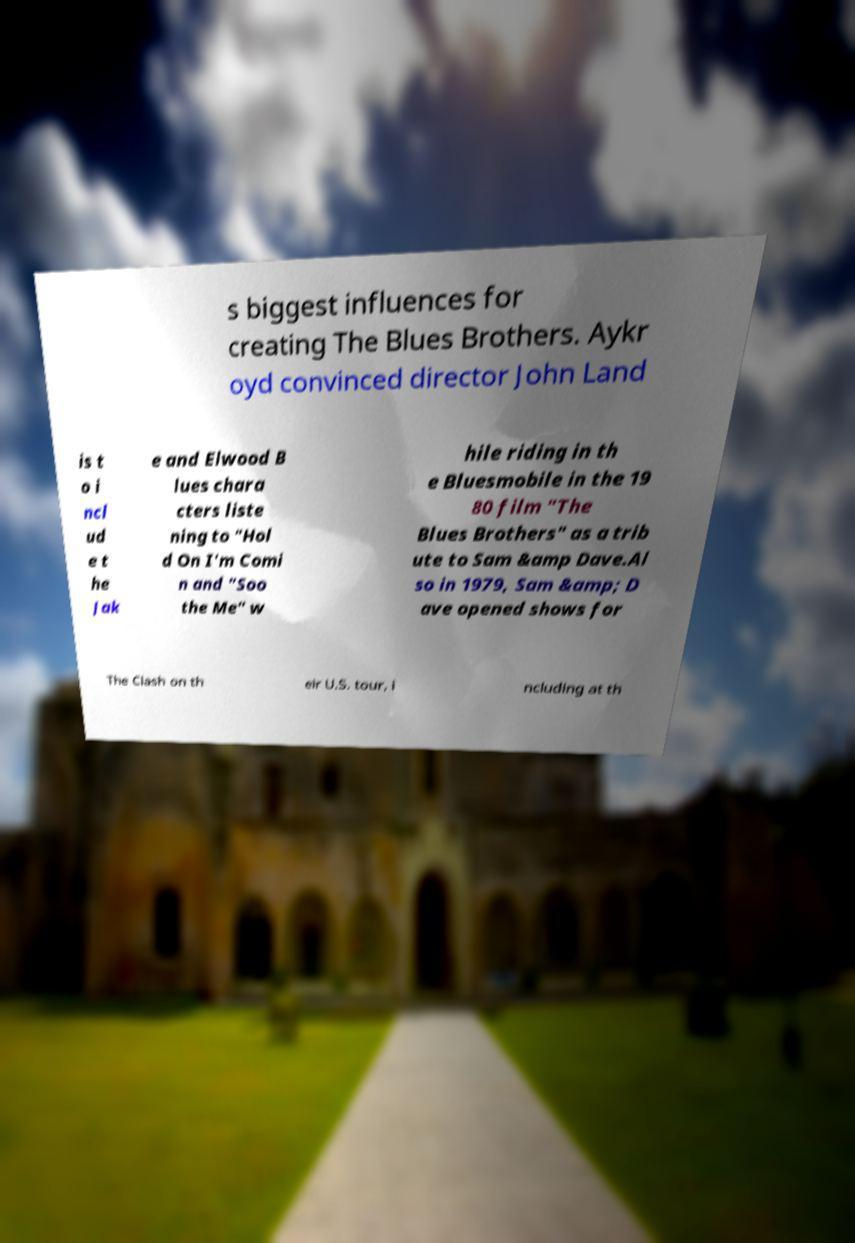There's text embedded in this image that I need extracted. Can you transcribe it verbatim? s biggest influences for creating The Blues Brothers. Aykr oyd convinced director John Land is t o i ncl ud e t he Jak e and Elwood B lues chara cters liste ning to "Hol d On I'm Comi n and "Soo the Me" w hile riding in th e Bluesmobile in the 19 80 film "The Blues Brothers" as a trib ute to Sam &amp Dave.Al so in 1979, Sam &amp; D ave opened shows for The Clash on th eir U.S. tour, i ncluding at th 